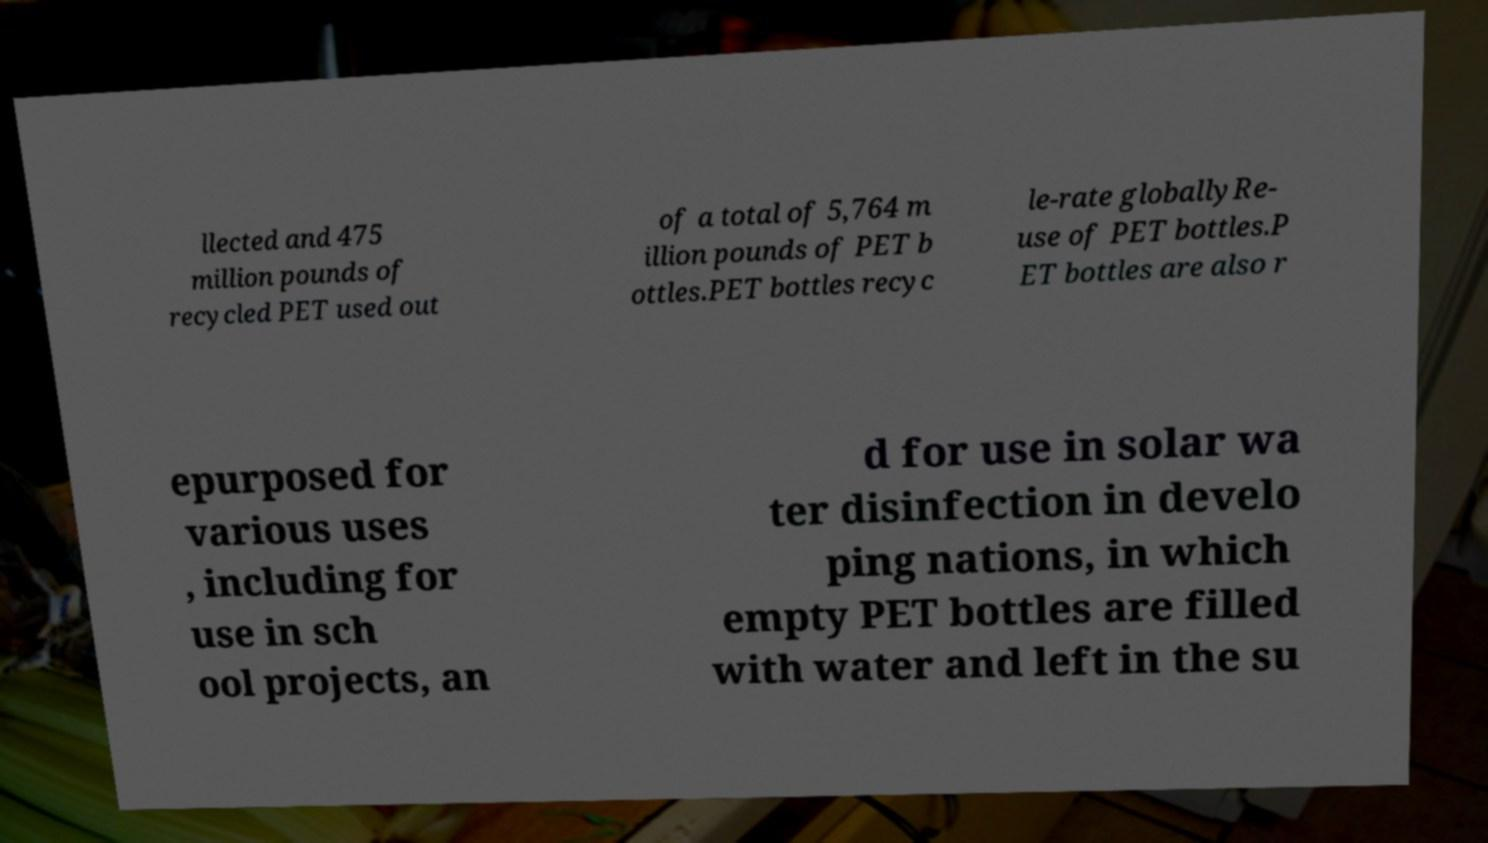Could you extract and type out the text from this image? llected and 475 million pounds of recycled PET used out of a total of 5,764 m illion pounds of PET b ottles.PET bottles recyc le-rate globallyRe- use of PET bottles.P ET bottles are also r epurposed for various uses , including for use in sch ool projects, an d for use in solar wa ter disinfection in develo ping nations, in which empty PET bottles are filled with water and left in the su 